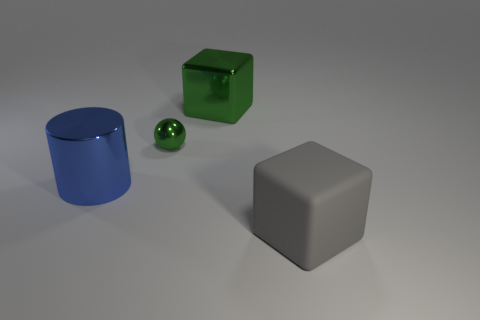Imagine these objects in everyday life. What purposes could they serve? In a real-world setting, the blue cylinder could serve as a container or a decorative vase, the big gray cube might be a minimalist stool or an abstract art piece, and the small green cube could be a paperweight or geometric decor. The sphere could potentially be a decorative ornament or a sleek paperweight. 